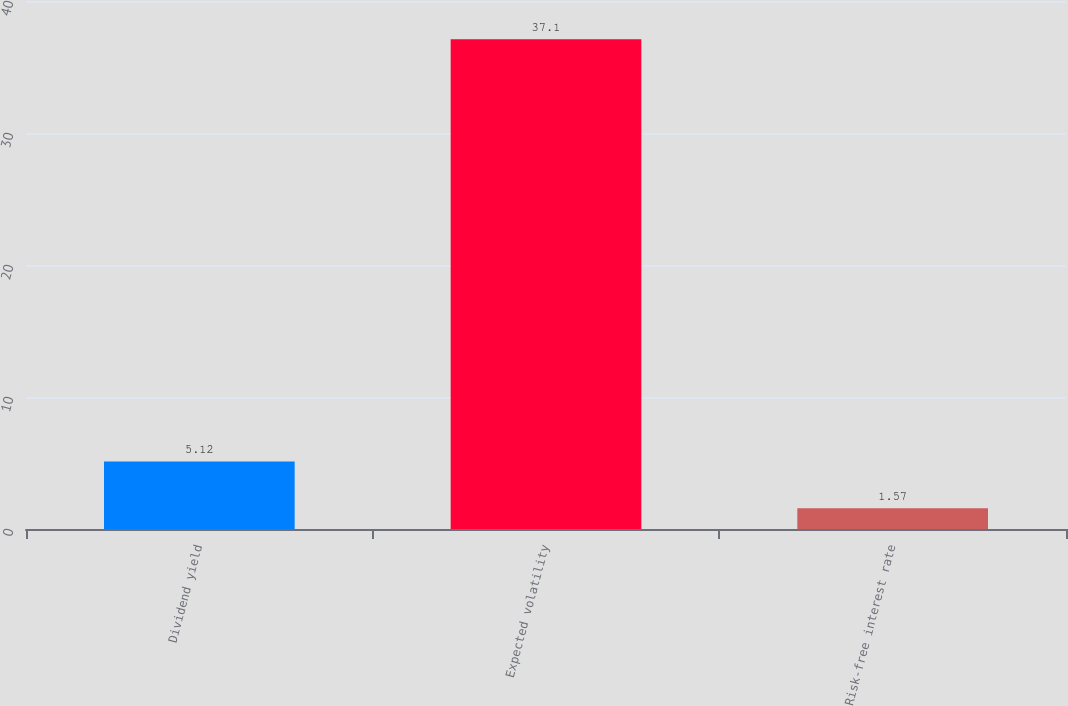Convert chart to OTSL. <chart><loc_0><loc_0><loc_500><loc_500><bar_chart><fcel>Dividend yield<fcel>Expected volatility<fcel>Risk-free interest rate<nl><fcel>5.12<fcel>37.1<fcel>1.57<nl></chart> 